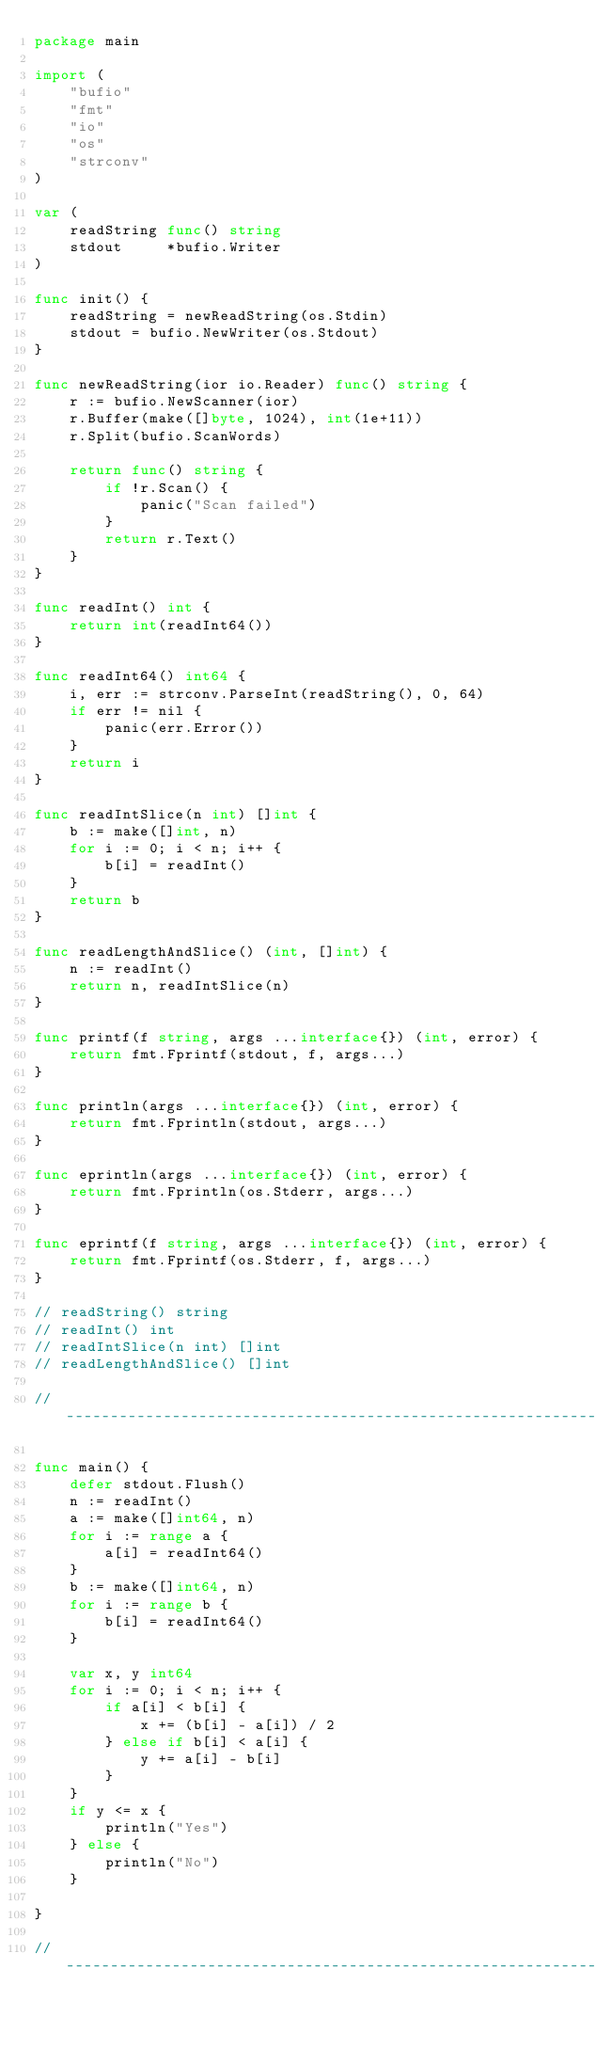<code> <loc_0><loc_0><loc_500><loc_500><_Go_>package main

import (
	"bufio"
	"fmt"
	"io"
	"os"
	"strconv"
)

var (
	readString func() string
	stdout     *bufio.Writer
)

func init() {
	readString = newReadString(os.Stdin)
	stdout = bufio.NewWriter(os.Stdout)
}

func newReadString(ior io.Reader) func() string {
	r := bufio.NewScanner(ior)
	r.Buffer(make([]byte, 1024), int(1e+11))
	r.Split(bufio.ScanWords)

	return func() string {
		if !r.Scan() {
			panic("Scan failed")
		}
		return r.Text()
	}
}

func readInt() int {
	return int(readInt64())
}

func readInt64() int64 {
	i, err := strconv.ParseInt(readString(), 0, 64)
	if err != nil {
		panic(err.Error())
	}
	return i
}

func readIntSlice(n int) []int {
	b := make([]int, n)
	for i := 0; i < n; i++ {
		b[i] = readInt()
	}
	return b
}

func readLengthAndSlice() (int, []int) {
	n := readInt()
	return n, readIntSlice(n)
}

func printf(f string, args ...interface{}) (int, error) {
	return fmt.Fprintf(stdout, f, args...)
}

func println(args ...interface{}) (int, error) {
	return fmt.Fprintln(stdout, args...)
}

func eprintln(args ...interface{}) (int, error) {
	return fmt.Fprintln(os.Stderr, args...)
}

func eprintf(f string, args ...interface{}) (int, error) {
	return fmt.Fprintf(os.Stderr, f, args...)
}

// readString() string
// readInt() int
// readIntSlice(n int) []int
// readLengthAndSlice() []int

// -----------------------------------------------------------------------------

func main() {
	defer stdout.Flush()
	n := readInt()
	a := make([]int64, n)
	for i := range a {
		a[i] = readInt64()
	}
	b := make([]int64, n)
	for i := range b {
		b[i] = readInt64()
	}

	var x, y int64
	for i := 0; i < n; i++ {
		if a[i] < b[i] {
			x += (b[i] - a[i]) / 2
		} else if b[i] < a[i] {
			y += a[i] - b[i]
		}
	}
	if y <= x {
		println("Yes")
	} else {
		println("No")
	}

}

// -----------------------------------------------------------------------------
</code> 